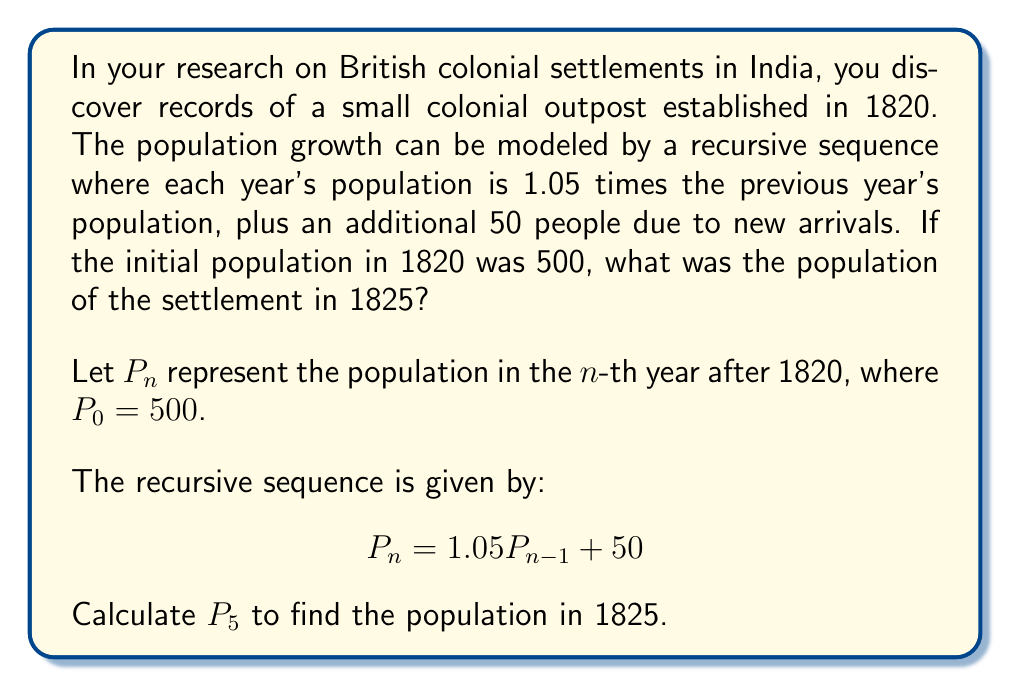Could you help me with this problem? To solve this problem, we need to apply the recursive sequence formula for each year from 1820 to 1825. Let's calculate step by step:

1) For 1820 (n = 0): $P_0 = 500$ (given)

2) For 1821 (n = 1):
   $P_1 = 1.05P_0 + 50 = 1.05(500) + 50 = 525 + 50 = 575$

3) For 1822 (n = 2):
   $P_2 = 1.05P_1 + 50 = 1.05(575) + 50 = 603.75 + 50 = 653.75$

4) For 1823 (n = 3):
   $P_3 = 1.05P_2 + 50 = 1.05(653.75) + 50 = 686.4375 + 50 = 736.4375$

5) For 1824 (n = 4):
   $P_4 = 1.05P_3 + 50 = 1.05(736.4375) + 50 = 773.259375 + 50 = 823.259375$

6) For 1825 (n = 5):
   $P_5 = 1.05P_4 + 50 = 1.05(823.259375) + 50 = 864.42234375 + 50 = 914.42234375$

Therefore, the population in 1825 was approximately 914 people (rounded to the nearest whole number).
Answer: 914 people 